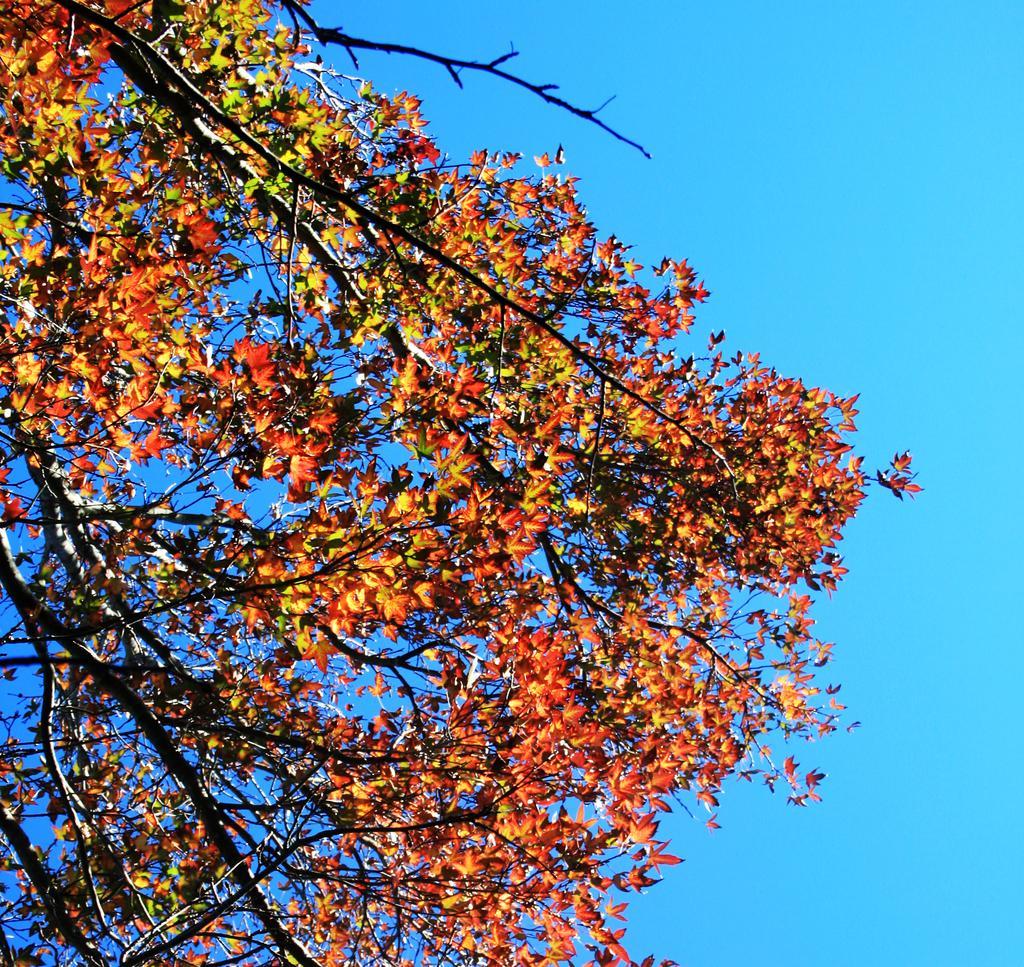Describe this image in one or two sentences. In this image, there are tree branches to which there are leaves which are in orange color. 